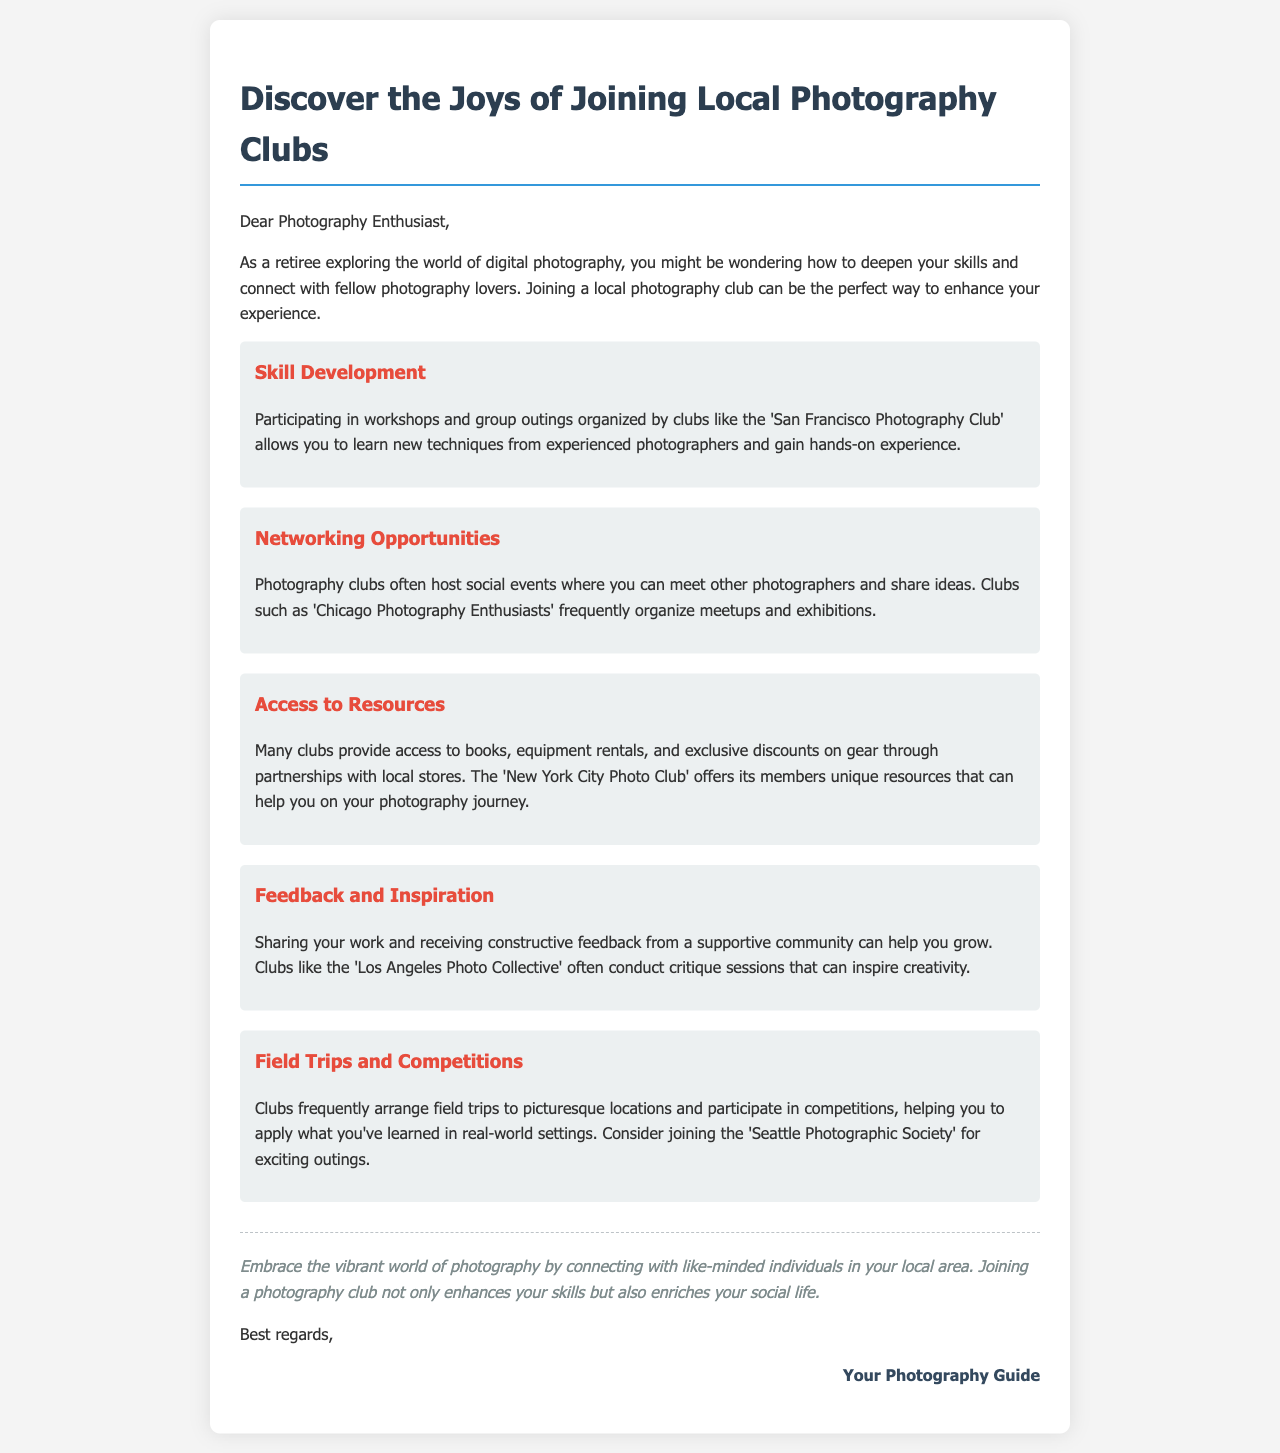What is the main purpose of joining a photography club? The document states that joining a photography club can enhance your experience in exploring digital photography.
Answer: Enhance experience Which club offers access to unique resources for members? The document mentions that the New York City Photo Club offers its members unique resources.
Answer: New York City Photo Club What type of events do photography clubs often host? The document indicates that photography clubs often host social events where photographers can meet and share ideas.
Answer: Social events What benefit do clubs like the Los Angeles Photo Collective provide? The document highlights that clubs like the Los Angeles Photo Collective conduct critique sessions to inspire creativity.
Answer: Critique sessions How can field trips help photographers? The document suggests that field trips help photographers apply what they've learned in real-world settings.
Answer: Apply learning What is one opportunity for skill development mentioned? The document states that participating in workshops allows you to learn new techniques.
Answer: Workshops Which photography club is mentioned for exciting outings? The document refers to the Seattle Photographic Society for exciting outings.
Answer: Seattle Photographic Society How does joining a photography club affect social life? The conclusion states that joining a photography club enriches your social life.
Answer: Enriches social life 